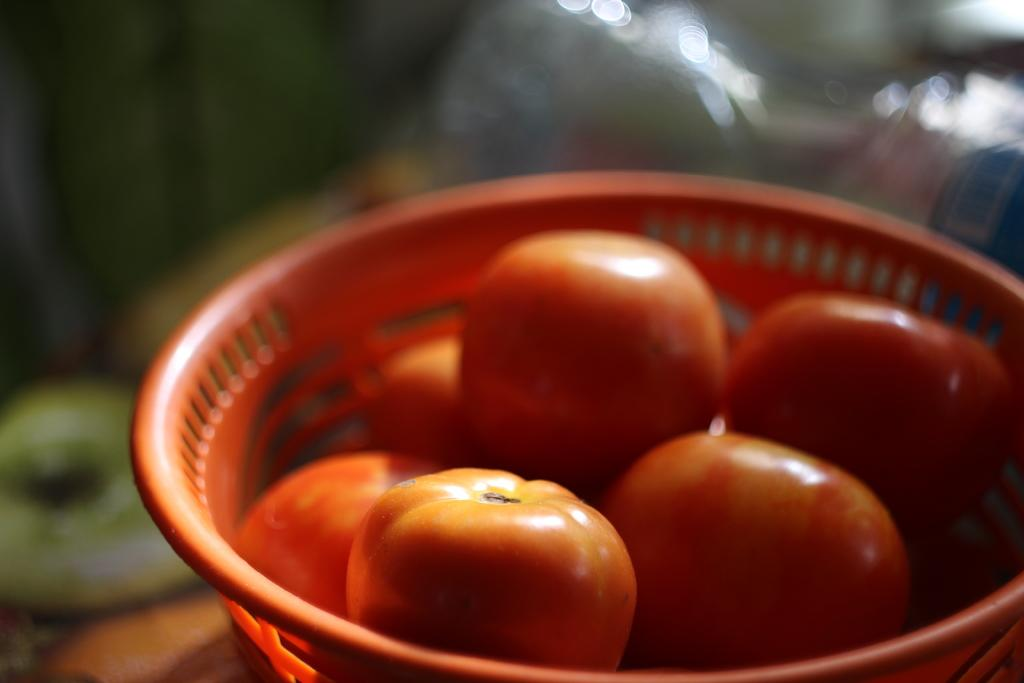What type of fruit is present in the image? There are red color tomatoes in the image. How are the tomatoes contained in the image? The tomatoes are in a red color plastic basket. Can you describe the quality of the image's background? The image is blurry in the background. What type of flame can be seen coming from the tomatoes in the image? There is no flame present in the image; it features red color tomatoes in a plastic basket. 